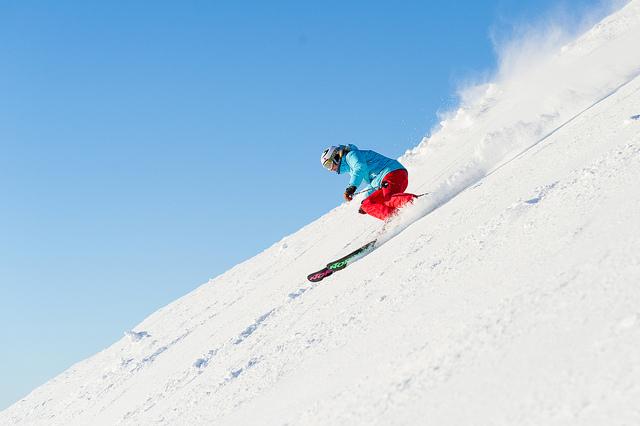Is she moving slowly?
Be succinct. No. What is the viscosity of the snow?
Quick response, please. Fluffy. Is the person wearing the right outfit for skiing?
Write a very short answer. Yes. Is this person snowboarding?
Short answer required. No. What color is his helmet?
Be succinct. White. Are there clouds in the sky?
Write a very short answer. No. 